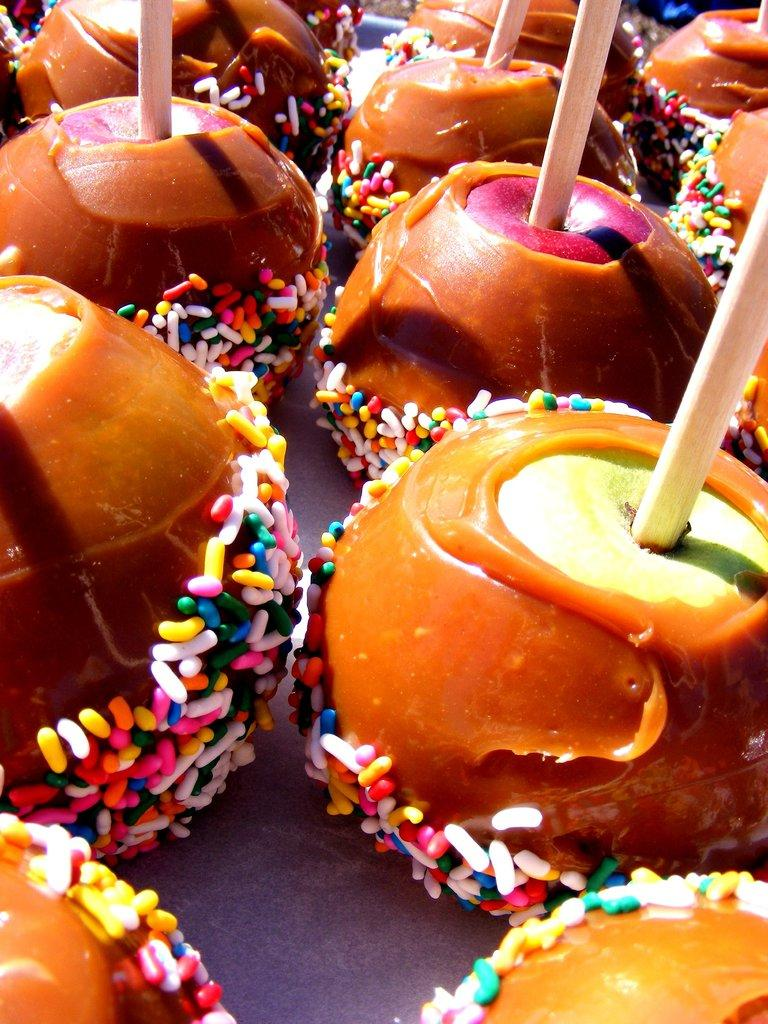What types of food are present in the image? There are different desserts in the image. How are the desserts prepared or served? Wooden sticks are inserted into the desserts. What type of invention is being demonstrated in the image? There is no invention being demonstrated in the image; it features desserts with wooden sticks inserted into them. What type of underwear is visible in the image? There is no underwear present in the image. 